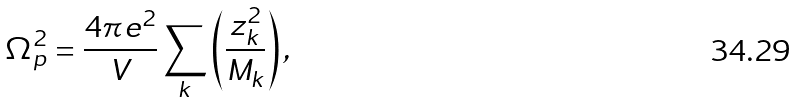<formula> <loc_0><loc_0><loc_500><loc_500>\Omega _ { p } ^ { 2 } = \frac { 4 \pi e ^ { 2 } } { V } \sum _ { k } \left ( \frac { z _ { k } ^ { 2 } } { M _ { k } } \right ) ,</formula> 